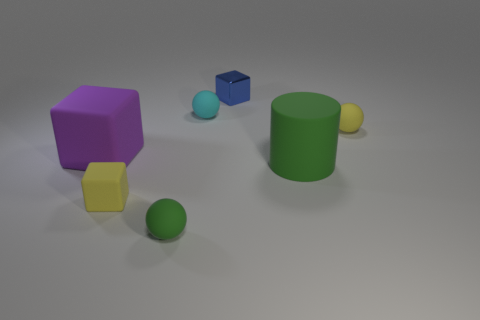Add 2 tiny purple metal objects. How many objects exist? 9 Subtract all cylinders. How many objects are left? 6 Add 2 small yellow shiny spheres. How many small yellow shiny spheres exist? 2 Subtract 0 cyan cylinders. How many objects are left? 7 Subtract all blue cubes. Subtract all small blocks. How many objects are left? 4 Add 5 big purple things. How many big purple things are left? 6 